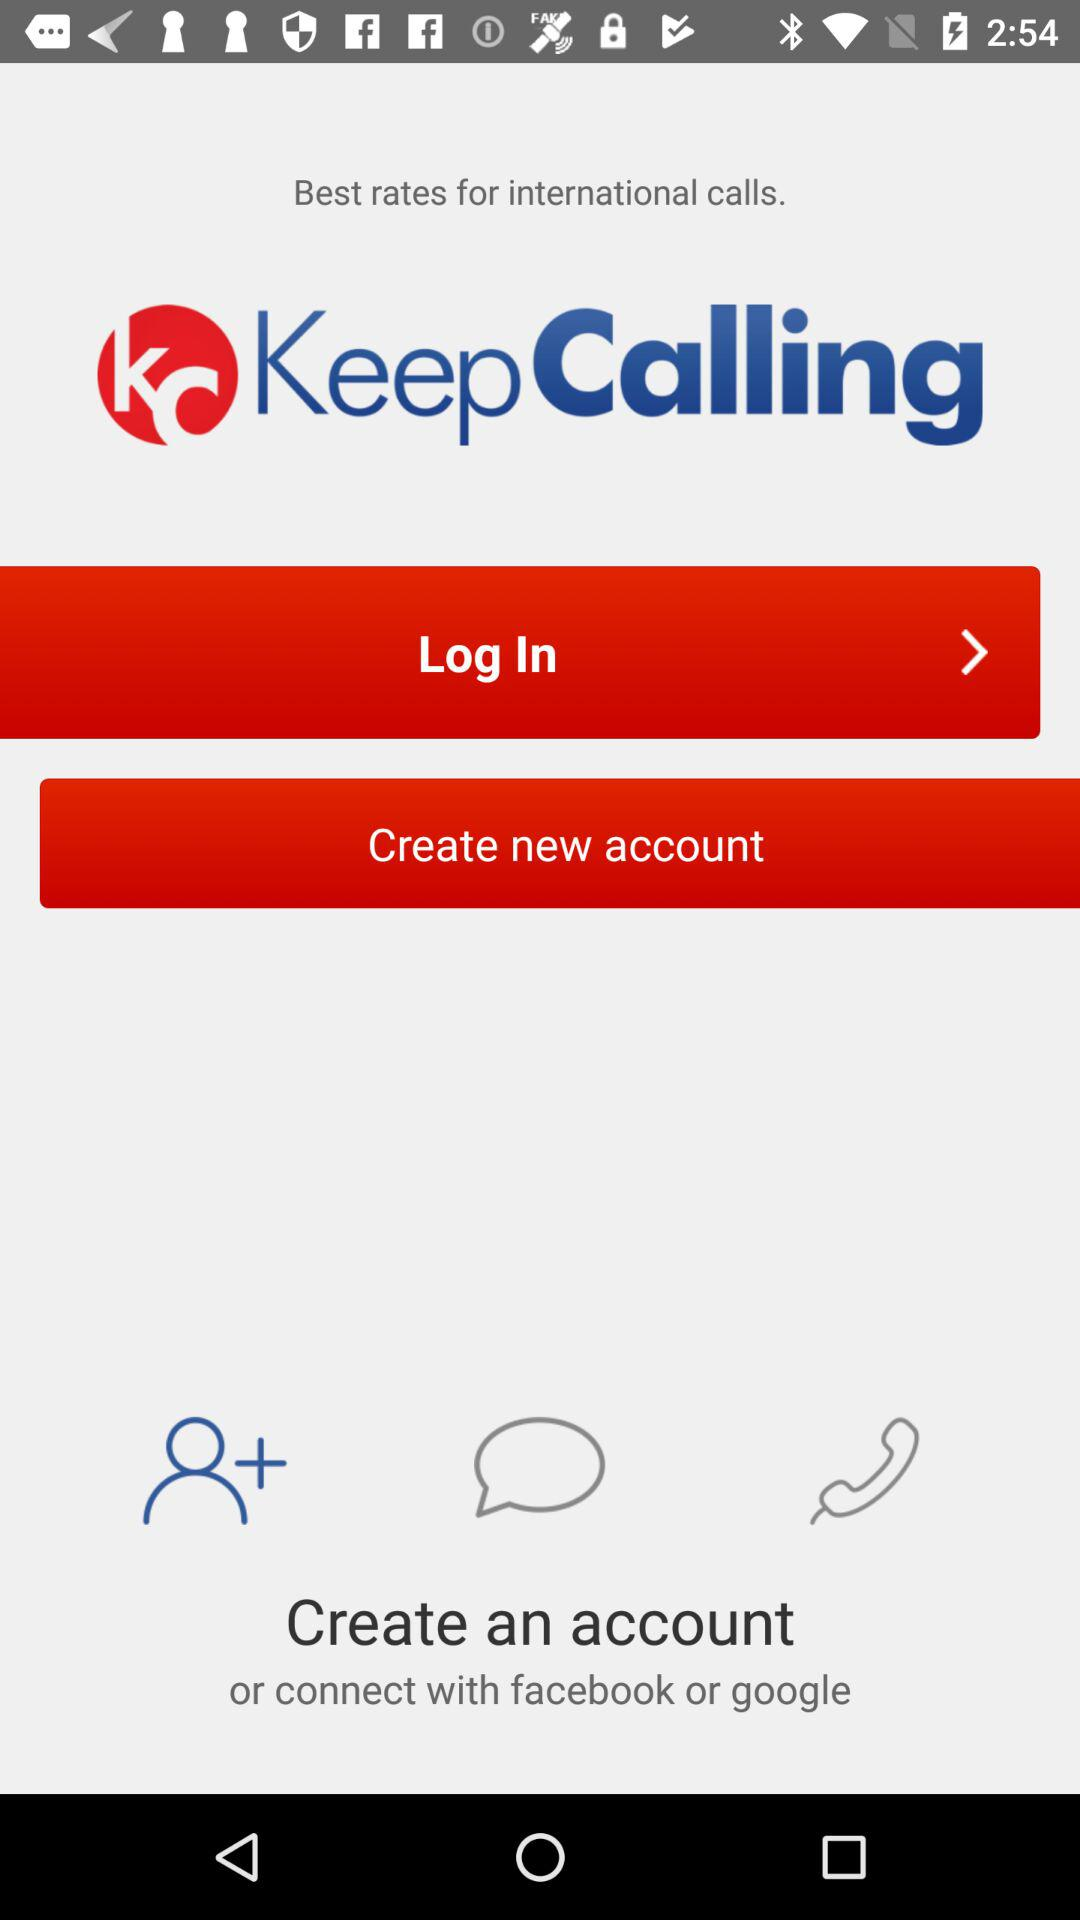What are the different options through which we can log in? The different options to log in are "Facebook or Google". 